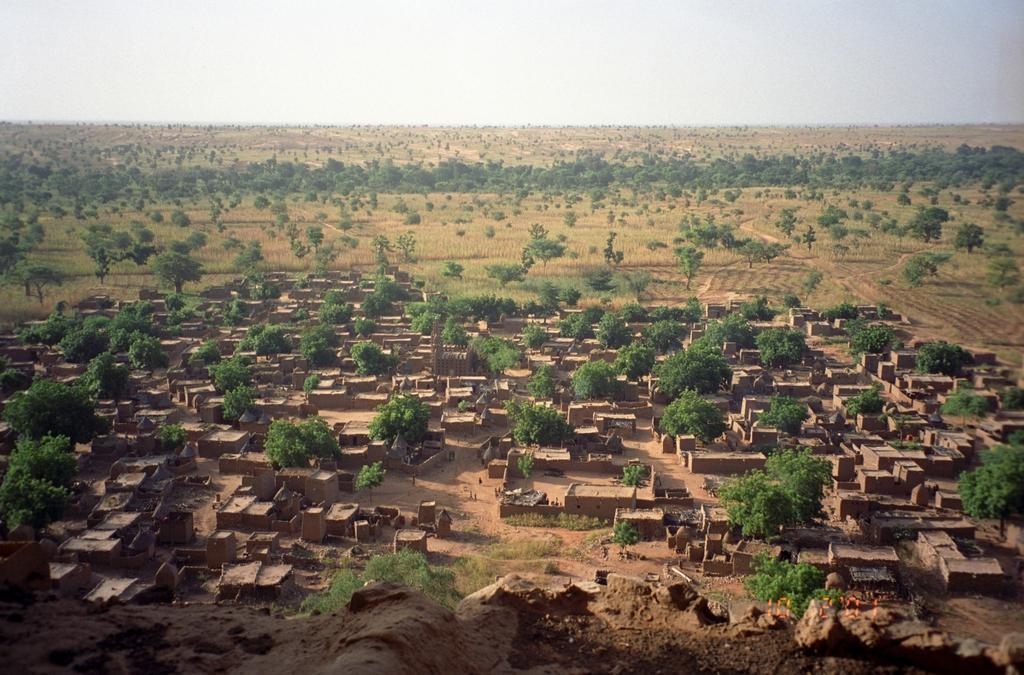Describe this image in one or two sentences. In this image we can see the houses, trees and grass. In the background, we can see the sky. 